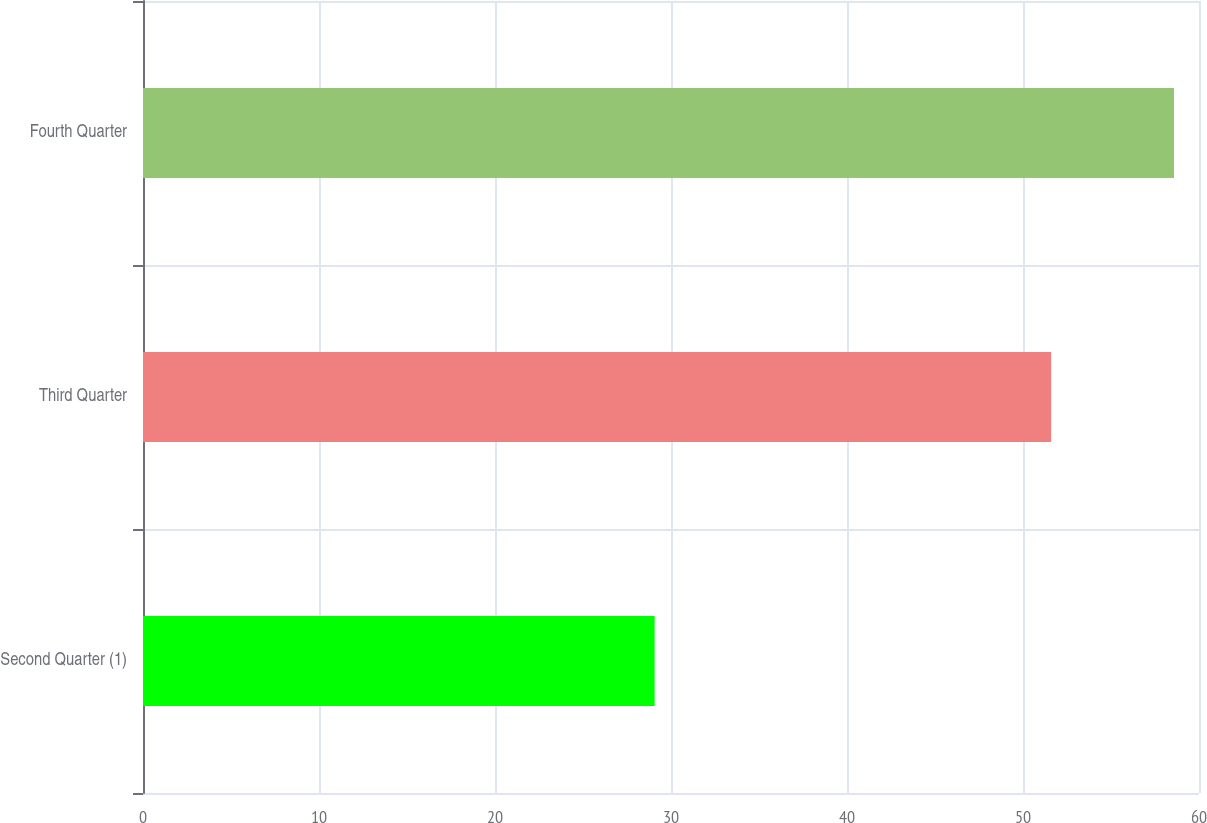<chart> <loc_0><loc_0><loc_500><loc_500><bar_chart><fcel>Second Quarter (1)<fcel>Third Quarter<fcel>Fourth Quarter<nl><fcel>29.07<fcel>51.6<fcel>58.58<nl></chart> 